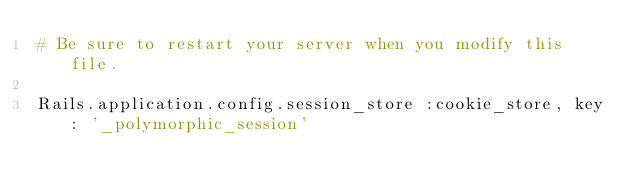Convert code to text. <code><loc_0><loc_0><loc_500><loc_500><_Ruby_># Be sure to restart your server when you modify this file.

Rails.application.config.session_store :cookie_store, key: '_polymorphic_session'
</code> 